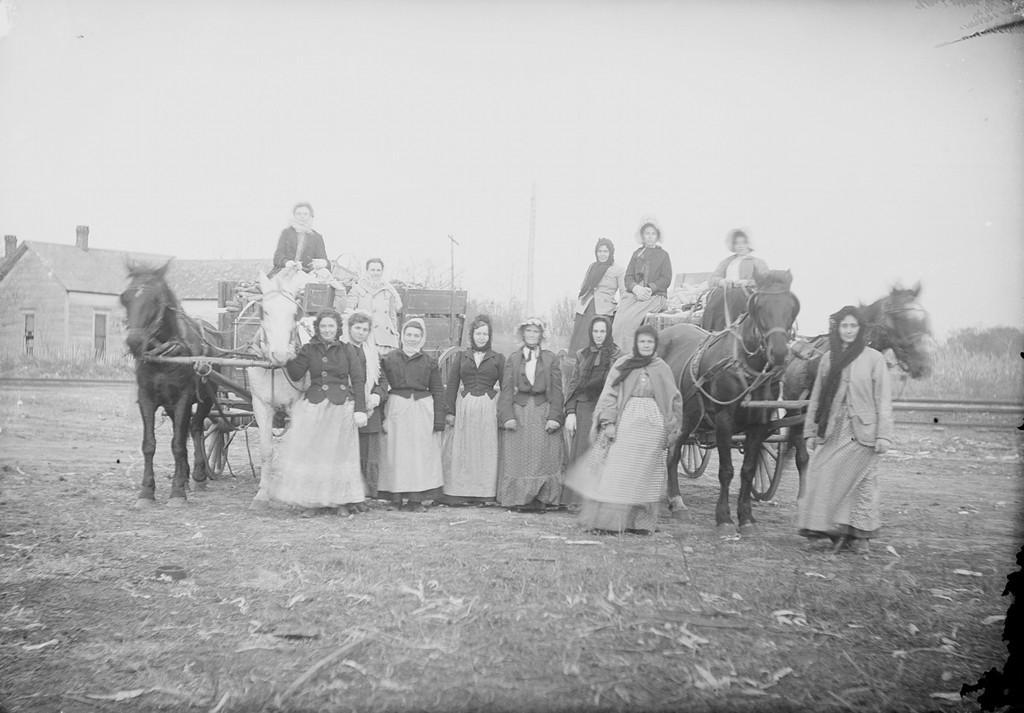How many people are in the image? There is a group of people in the image, but the exact number cannot be determined from the provided facts. What are the people in the image doing? Some people are standing on the ground, and some are sitting on horse carts. What can be seen in the background of the image? There is a house, trees, and the sky visible in the background of the image. What type of quill is being used by the person in the image? There is no quill present in the image; it features a group of people, some standing and some sitting on horse carts, with a background that includes a house, trees, and the sky. Can you tell me what joke the person in the image is telling? There is no indication of anyone telling a joke in the image; it simply shows a group of people, some standing and some sitting on horse carts, with a background that includes a house, trees, and the sky. 